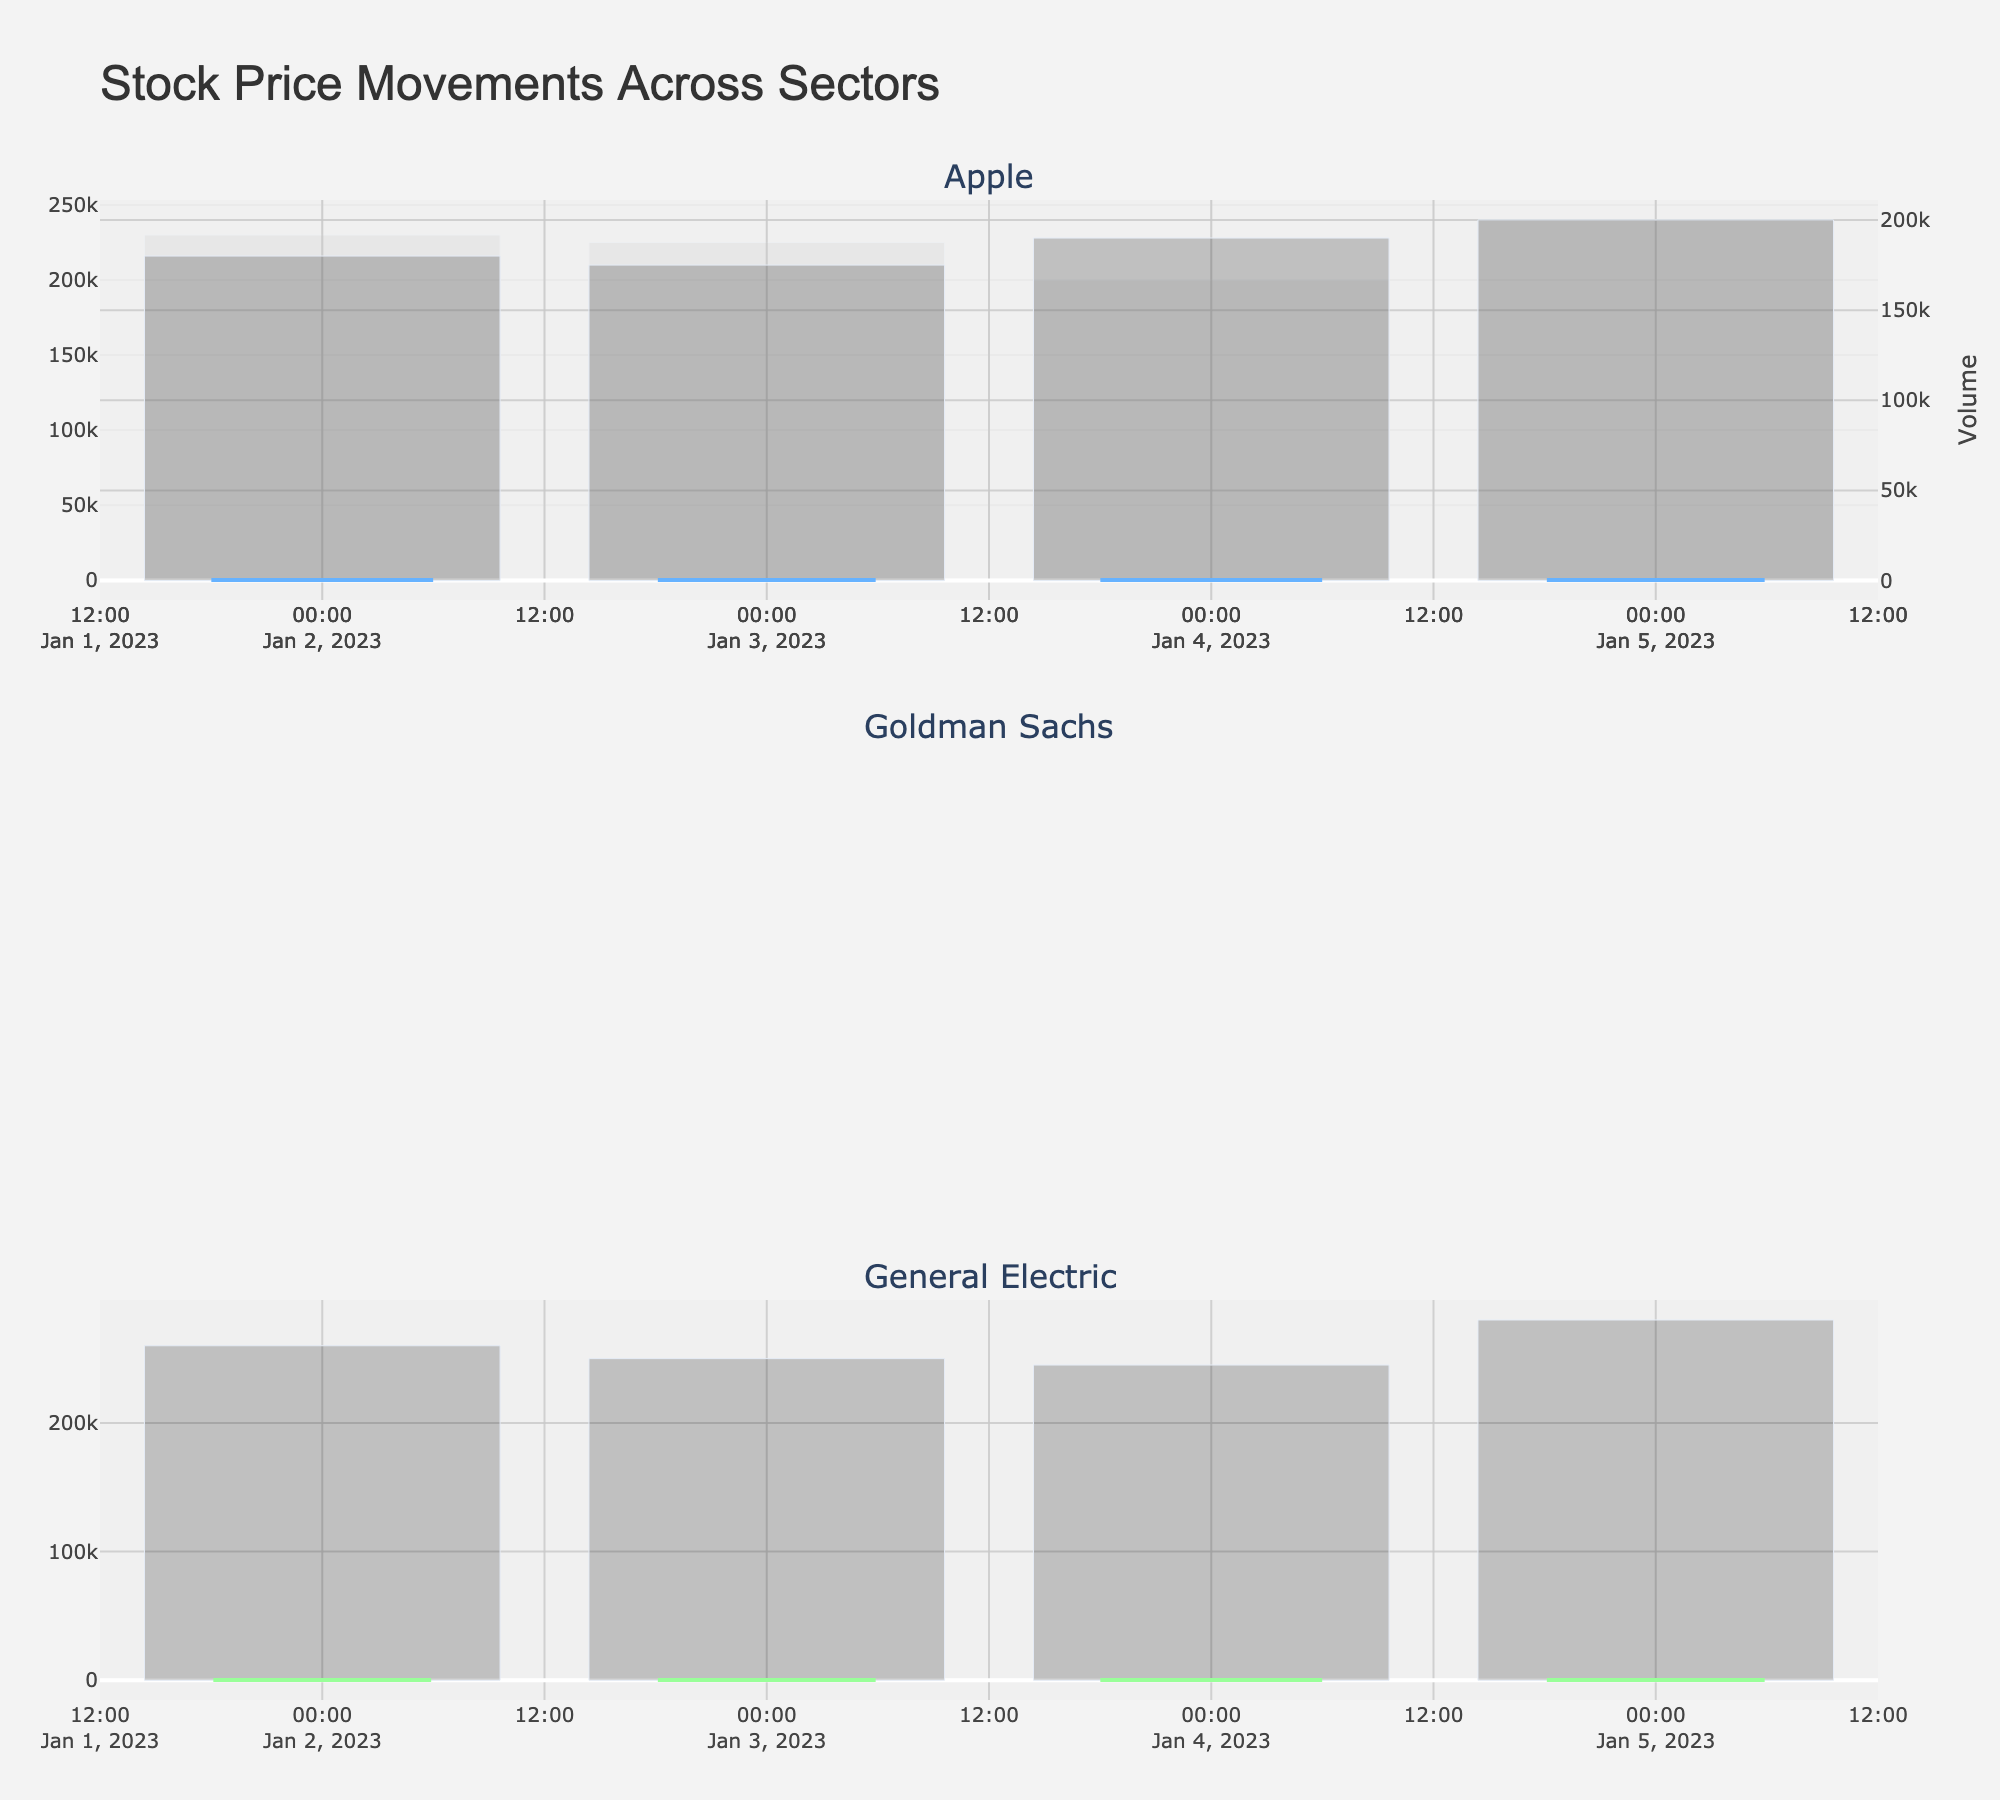What are the different stocks represented in the plot? The subplot titles represent the names of the stocks, and we can see three titles: Apple, Goldman Sachs, and General Electric.
Answer: Apple, Goldman Sachs, General Electric Which stock sector shows the highest closing price on 2023-01-05? By examining the candlesticks for the date 2023-01-05, we can see that Goldman Sachs, in the financial sector, has the highest closing price at 370.
Answer: Financial (Goldman Sachs) How does the volume traded in General Electric compare to Apple on 2023-01-05? By comparing the volume bars on the date 2023-01-05, we can see that General Electric has a volume of 280,000, while Apple has 240,000, meaning General Electric has a higher trading volume.
Answer: General Electric has a higher volume Which stock experienced the largest range between high and low prices on 2023-01-02? To find this, we compare the high and low prices of each stock on 2023-01-02. We subtract the low from the high for each stock. For Apple: 123-119=4, for Goldman Sachs: 360-345=15, for General Electric: 215-208=7. Goldman Sachs shows the largest range.
Answer: Goldman Sachs What is the trend in Goldman Sachs' closing prices from 2023-01-02 to 2023-01-05? Observing the candlestick closing tails, Goldman Sachs shows a consistently increasing trend from 355 on 2023-01-02 to 370 on 2023-01-05.
Answer: Increasing trend How does the volatility in the Consumer Goods sector compare to the Industrial sector over the four days? Comparing the range (high-low) of Apple (Consumer Goods) and General Electric (Industrial) over the four days, we see Apple's ranges are 4, 3, 3, 3, while General Electric's ranges are 7, 6, 6, 6. General Electric shows more volatility.
Answer: Industrial sector is more volatile Which day had the highest trading volume for all stocks? By looking at the volume bars for each stock, the trading volume on 2023-01-05 is the highest across all stocks: Apple (240,000), Goldman Sachs (200,000), General Electric (280,000).
Answer: 2023-01-05 What is the average closing price of General Electric over the four days? Adding the closing prices of General Electric for four days: (213 + 215 + 216 + 218) and dividing by 4, we get (862/4) = 215.5.
Answer: 215.5 